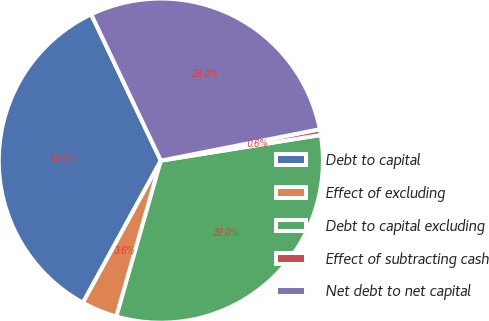<chart> <loc_0><loc_0><loc_500><loc_500><pie_chart><fcel>Debt to capital<fcel>Effect of excluding<fcel>Debt to capital excluding<fcel>Effect of subtracting cash<fcel>Net debt to net capital<nl><fcel>34.95%<fcel>3.56%<fcel>31.96%<fcel>0.57%<fcel>28.97%<nl></chart> 